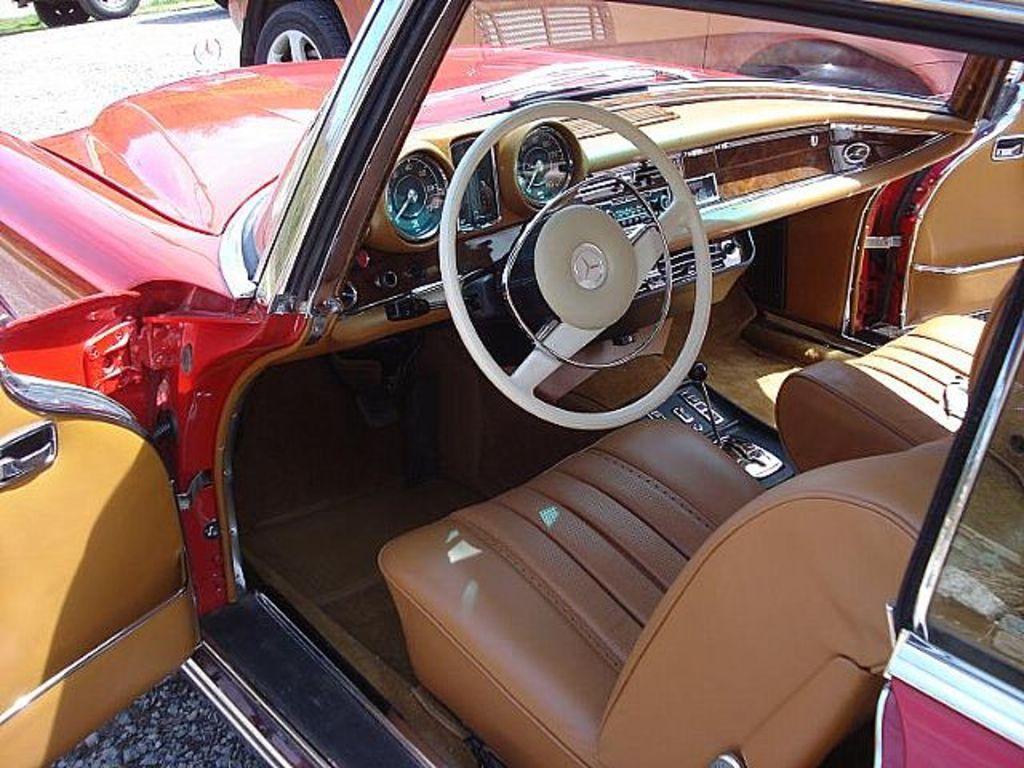Please provide a concise description of this image. In this image I can see a car which is red in color and I can see the dashboard of the car, the steering, the speedometer, the door and the seats of the car which are brown in color. In the background I can see few other vehicles on the road. 